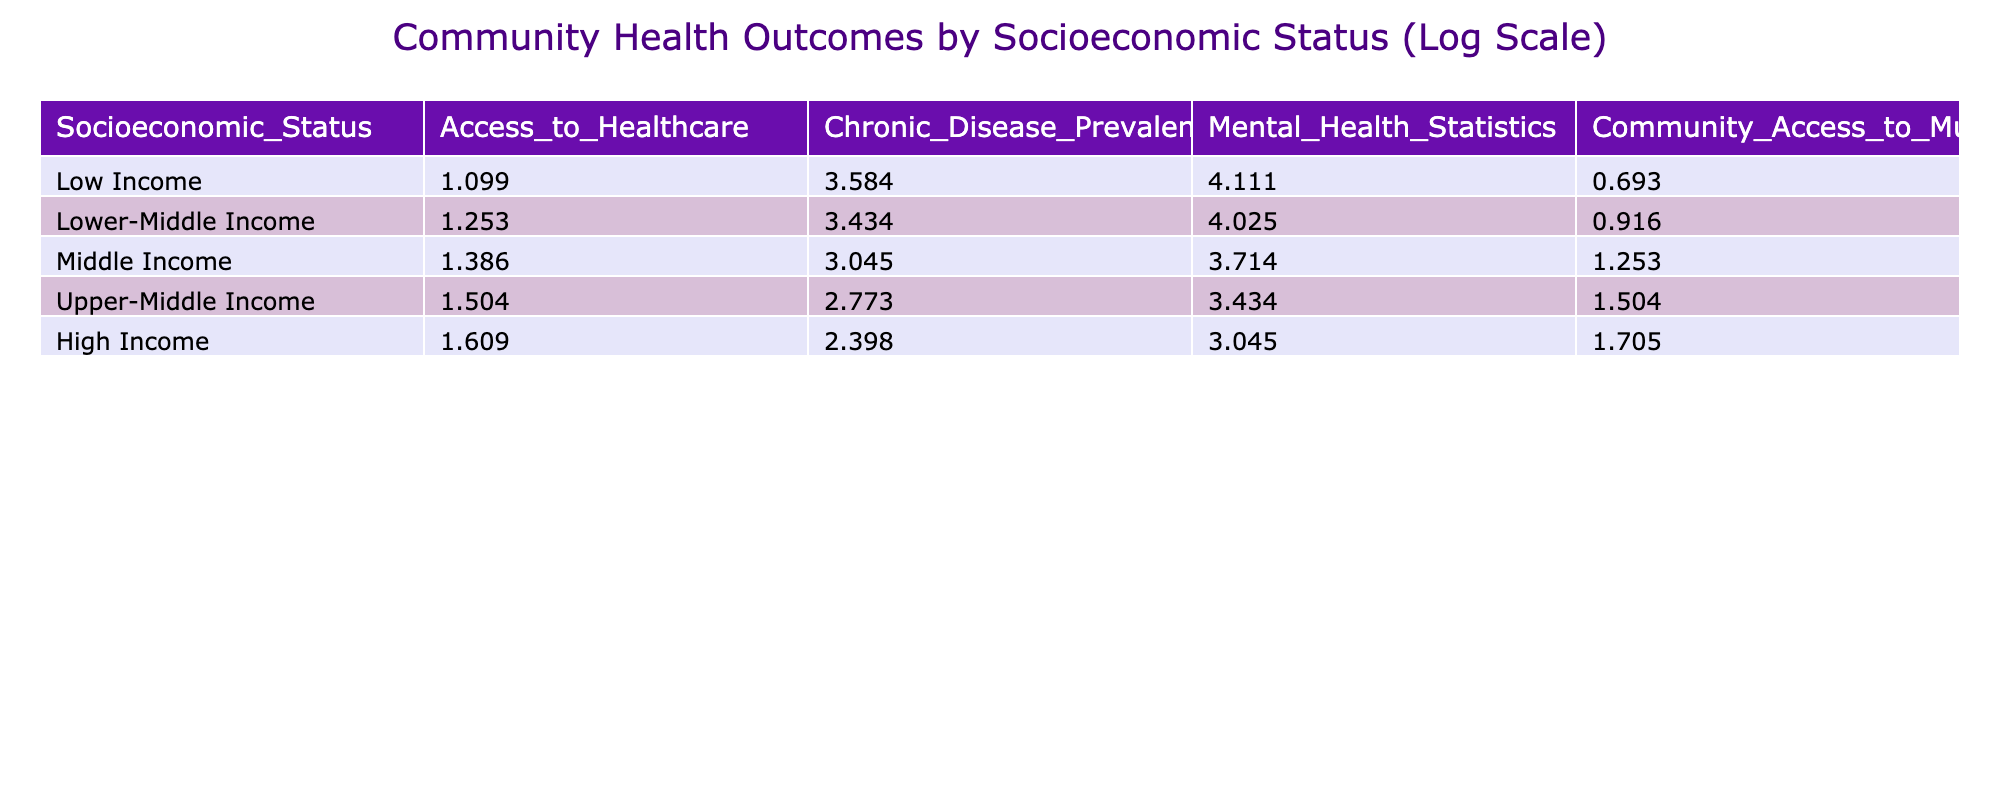What is the Access to Healthcare value for High Income? The Access to Healthcare value for High Income is found in the corresponding row under that category. It shows a value of 4.0.
Answer: 4.0 What is the difference in Chronic Disease Prevalence between Low Income and High Income? To find the difference, we identify the values for Chronic Disease Prevalence: Low Income is 35.0 and High Income is 10.0. The difference is calculated as 35.0 - 10.0 = 25.0.
Answer: 25.0 Is the Mental Health Statistics value for Upper-Middle Income higher than that for Lower-Middle Income? Comparing the values, Upper-Middle Income shows a Mental Health Statistics value of 30.0 while Lower-Middle Income shows 55.0. Since 30.0 is less than 55.0, the statement is false.
Answer: No What is the average Community Access to Music Events for Middle Income and Upper-Middle Income? For Middle Income, the Community Access to Music Events value is 2.5, and for Upper-Middle Income, it is 3.5. The average is found by adding these values (2.5 + 3.5) and dividing by 2, which gives (6.0 / 2) = 3.0.
Answer: 3.0 Which socioeconomic status has the highest value for Community Access to Music Events? Looking through the Community Access to Music Events column, High Income has the highest value of 4.5, compared to other categories.
Answer: High Income How does the Access to Healthcare for Lower-Middle Income compare with that for Middle Income? The Access to Healthcare value for Lower-Middle Income is 2.5, while for Middle Income, it is 3.0. Middle Income provides better access, so the difference is 3.0 - 2.5 = 0.5.
Answer: Middle Income has better access by 0.5 Does having a higher income correlate with a lower Chronic Disease Prevalence? By examining the Chronic Disease Prevalence values, we notice that as income increases (from Low Income to High Income), the Chronic Disease Prevalence decreases from 35.0 to 10.0. This suggests a correlation.
Answer: Yes What is the sum of Access to Healthcare values for all income groups? We find the Access to Healthcare values: 2.0 (Low Income) + 2.5 (Lower-Middle Income) + 3.0 (Middle Income) + 3.5 (Upper-Middle Income) + 4.0 (High Income). The total sum is (2.0 + 2.5 + 3.0 + 3.5 + 4.0) = 15.0.
Answer: 15.0 